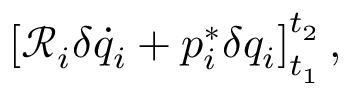<formula> <loc_0><loc_0><loc_500><loc_500>\left [ \mathcal { R } _ { i } \delta \dot { q } _ { i } + p _ { i } ^ { * } \delta { q } _ { i } \right ] _ { t _ { 1 } } ^ { t _ { 2 } } ,</formula> 